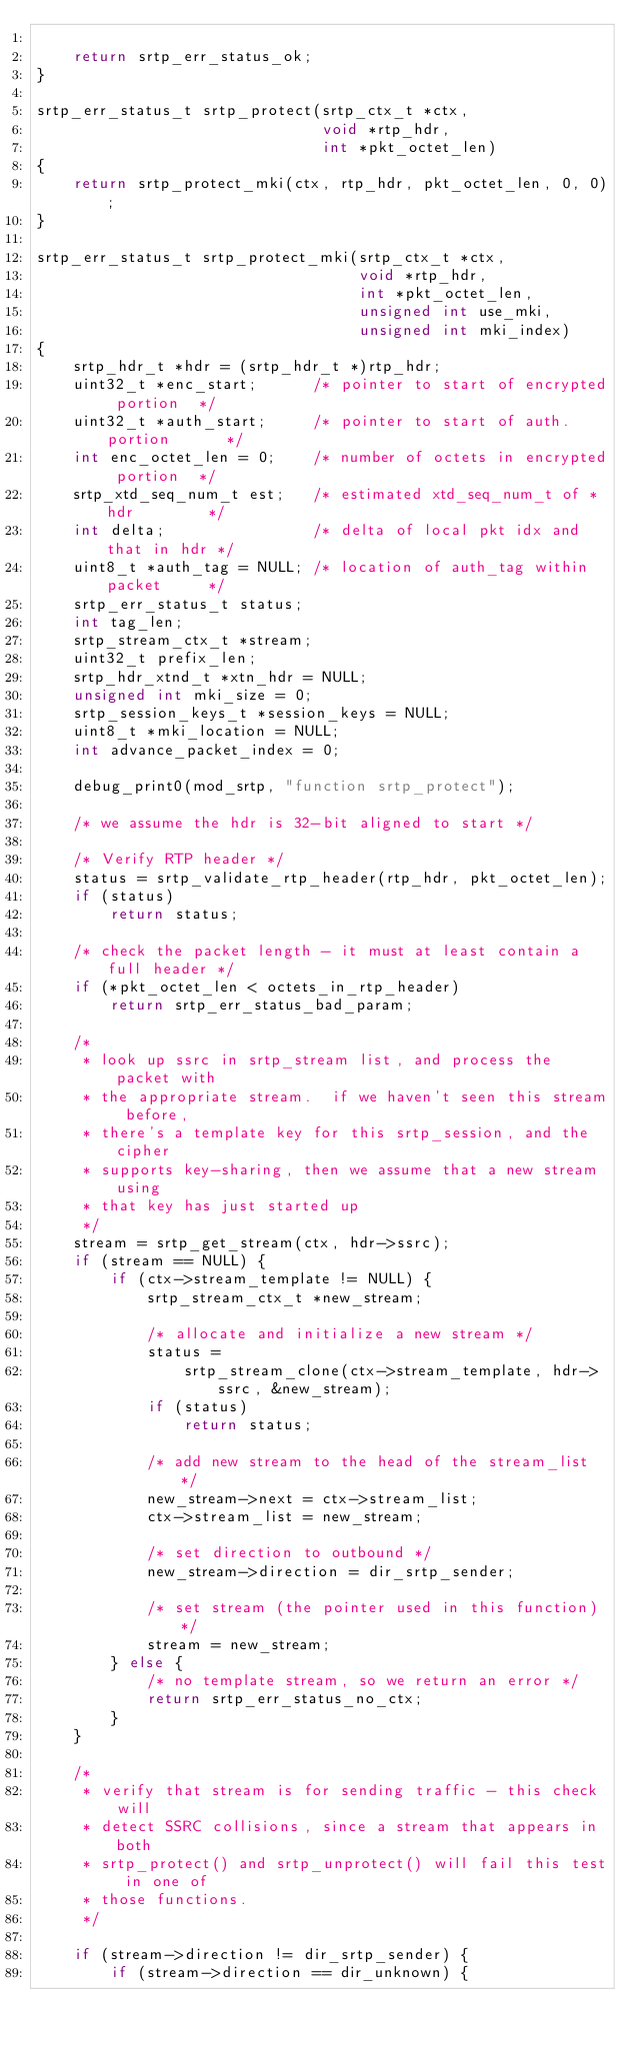<code> <loc_0><loc_0><loc_500><loc_500><_C_>
    return srtp_err_status_ok;
}

srtp_err_status_t srtp_protect(srtp_ctx_t *ctx,
                               void *rtp_hdr,
                               int *pkt_octet_len)
{
    return srtp_protect_mki(ctx, rtp_hdr, pkt_octet_len, 0, 0);
}

srtp_err_status_t srtp_protect_mki(srtp_ctx_t *ctx,
                                   void *rtp_hdr,
                                   int *pkt_octet_len,
                                   unsigned int use_mki,
                                   unsigned int mki_index)
{
    srtp_hdr_t *hdr = (srtp_hdr_t *)rtp_hdr;
    uint32_t *enc_start;      /* pointer to start of encrypted portion  */
    uint32_t *auth_start;     /* pointer to start of auth. portion      */
    int enc_octet_len = 0;    /* number of octets in encrypted portion  */
    srtp_xtd_seq_num_t est;   /* estimated xtd_seq_num_t of *hdr        */
    int delta;                /* delta of local pkt idx and that in hdr */
    uint8_t *auth_tag = NULL; /* location of auth_tag within packet     */
    srtp_err_status_t status;
    int tag_len;
    srtp_stream_ctx_t *stream;
    uint32_t prefix_len;
    srtp_hdr_xtnd_t *xtn_hdr = NULL;
    unsigned int mki_size = 0;
    srtp_session_keys_t *session_keys = NULL;
    uint8_t *mki_location = NULL;
    int advance_packet_index = 0;

    debug_print0(mod_srtp, "function srtp_protect");

    /* we assume the hdr is 32-bit aligned to start */

    /* Verify RTP header */
    status = srtp_validate_rtp_header(rtp_hdr, pkt_octet_len);
    if (status)
        return status;

    /* check the packet length - it must at least contain a full header */
    if (*pkt_octet_len < octets_in_rtp_header)
        return srtp_err_status_bad_param;

    /*
     * look up ssrc in srtp_stream list, and process the packet with
     * the appropriate stream.  if we haven't seen this stream before,
     * there's a template key for this srtp_session, and the cipher
     * supports key-sharing, then we assume that a new stream using
     * that key has just started up
     */
    stream = srtp_get_stream(ctx, hdr->ssrc);
    if (stream == NULL) {
        if (ctx->stream_template != NULL) {
            srtp_stream_ctx_t *new_stream;

            /* allocate and initialize a new stream */
            status =
                srtp_stream_clone(ctx->stream_template, hdr->ssrc, &new_stream);
            if (status)
                return status;

            /* add new stream to the head of the stream_list */
            new_stream->next = ctx->stream_list;
            ctx->stream_list = new_stream;

            /* set direction to outbound */
            new_stream->direction = dir_srtp_sender;

            /* set stream (the pointer used in this function) */
            stream = new_stream;
        } else {
            /* no template stream, so we return an error */
            return srtp_err_status_no_ctx;
        }
    }

    /*
     * verify that stream is for sending traffic - this check will
     * detect SSRC collisions, since a stream that appears in both
     * srtp_protect() and srtp_unprotect() will fail this test in one of
     * those functions.
     */

    if (stream->direction != dir_srtp_sender) {
        if (stream->direction == dir_unknown) {</code> 